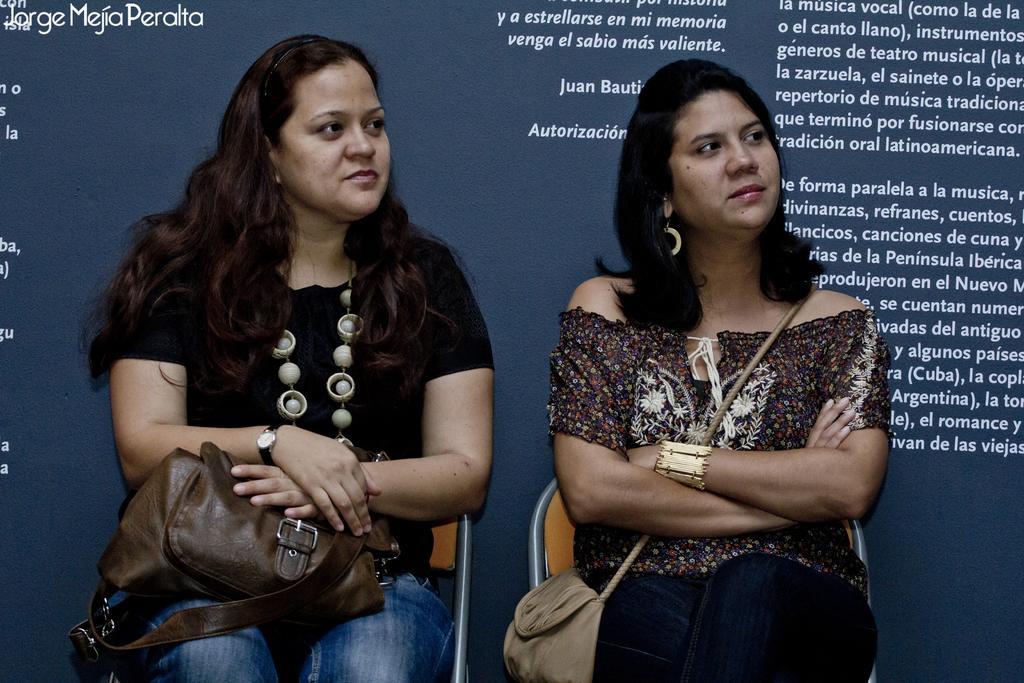Could you give a brief overview of what you see in this image? In the foreground of the picture there are two women sitting in chairs. In the background there is a banner. On the banner there is text. 